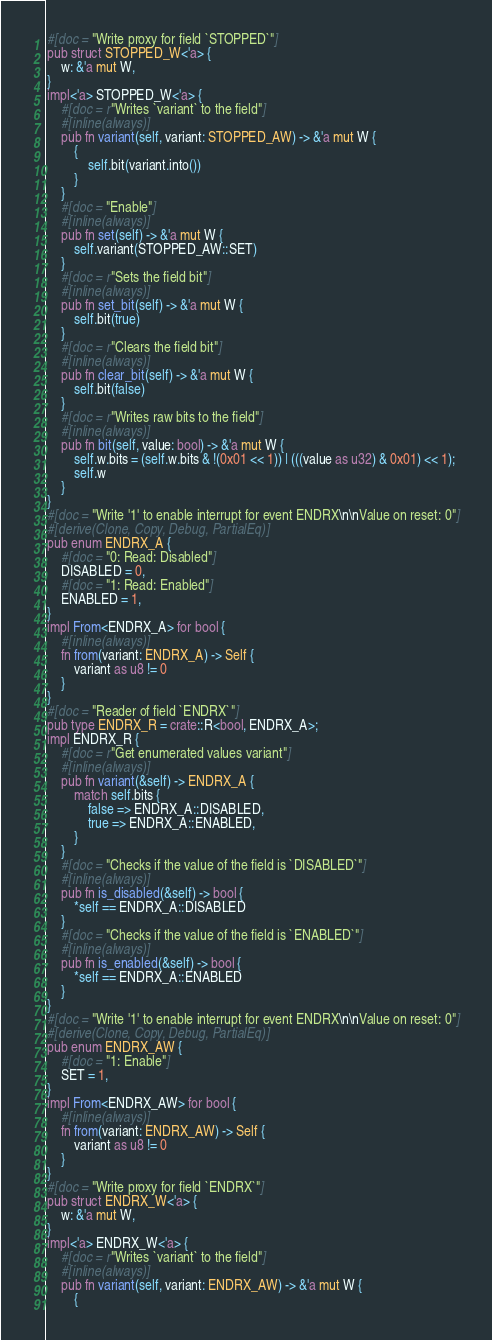<code> <loc_0><loc_0><loc_500><loc_500><_Rust_>#[doc = "Write proxy for field `STOPPED`"]
pub struct STOPPED_W<'a> {
    w: &'a mut W,
}
impl<'a> STOPPED_W<'a> {
    #[doc = r"Writes `variant` to the field"]
    #[inline(always)]
    pub fn variant(self, variant: STOPPED_AW) -> &'a mut W {
        {
            self.bit(variant.into())
        }
    }
    #[doc = "Enable"]
    #[inline(always)]
    pub fn set(self) -> &'a mut W {
        self.variant(STOPPED_AW::SET)
    }
    #[doc = r"Sets the field bit"]
    #[inline(always)]
    pub fn set_bit(self) -> &'a mut W {
        self.bit(true)
    }
    #[doc = r"Clears the field bit"]
    #[inline(always)]
    pub fn clear_bit(self) -> &'a mut W {
        self.bit(false)
    }
    #[doc = r"Writes raw bits to the field"]
    #[inline(always)]
    pub fn bit(self, value: bool) -> &'a mut W {
        self.w.bits = (self.w.bits & !(0x01 << 1)) | (((value as u32) & 0x01) << 1);
        self.w
    }
}
#[doc = "Write '1' to enable interrupt for event ENDRX\n\nValue on reset: 0"]
#[derive(Clone, Copy, Debug, PartialEq)]
pub enum ENDRX_A {
    #[doc = "0: Read: Disabled"]
    DISABLED = 0,
    #[doc = "1: Read: Enabled"]
    ENABLED = 1,
}
impl From<ENDRX_A> for bool {
    #[inline(always)]
    fn from(variant: ENDRX_A) -> Self {
        variant as u8 != 0
    }
}
#[doc = "Reader of field `ENDRX`"]
pub type ENDRX_R = crate::R<bool, ENDRX_A>;
impl ENDRX_R {
    #[doc = r"Get enumerated values variant"]
    #[inline(always)]
    pub fn variant(&self) -> ENDRX_A {
        match self.bits {
            false => ENDRX_A::DISABLED,
            true => ENDRX_A::ENABLED,
        }
    }
    #[doc = "Checks if the value of the field is `DISABLED`"]
    #[inline(always)]
    pub fn is_disabled(&self) -> bool {
        *self == ENDRX_A::DISABLED
    }
    #[doc = "Checks if the value of the field is `ENABLED`"]
    #[inline(always)]
    pub fn is_enabled(&self) -> bool {
        *self == ENDRX_A::ENABLED
    }
}
#[doc = "Write '1' to enable interrupt for event ENDRX\n\nValue on reset: 0"]
#[derive(Clone, Copy, Debug, PartialEq)]
pub enum ENDRX_AW {
    #[doc = "1: Enable"]
    SET = 1,
}
impl From<ENDRX_AW> for bool {
    #[inline(always)]
    fn from(variant: ENDRX_AW) -> Self {
        variant as u8 != 0
    }
}
#[doc = "Write proxy for field `ENDRX`"]
pub struct ENDRX_W<'a> {
    w: &'a mut W,
}
impl<'a> ENDRX_W<'a> {
    #[doc = r"Writes `variant` to the field"]
    #[inline(always)]
    pub fn variant(self, variant: ENDRX_AW) -> &'a mut W {
        {</code> 